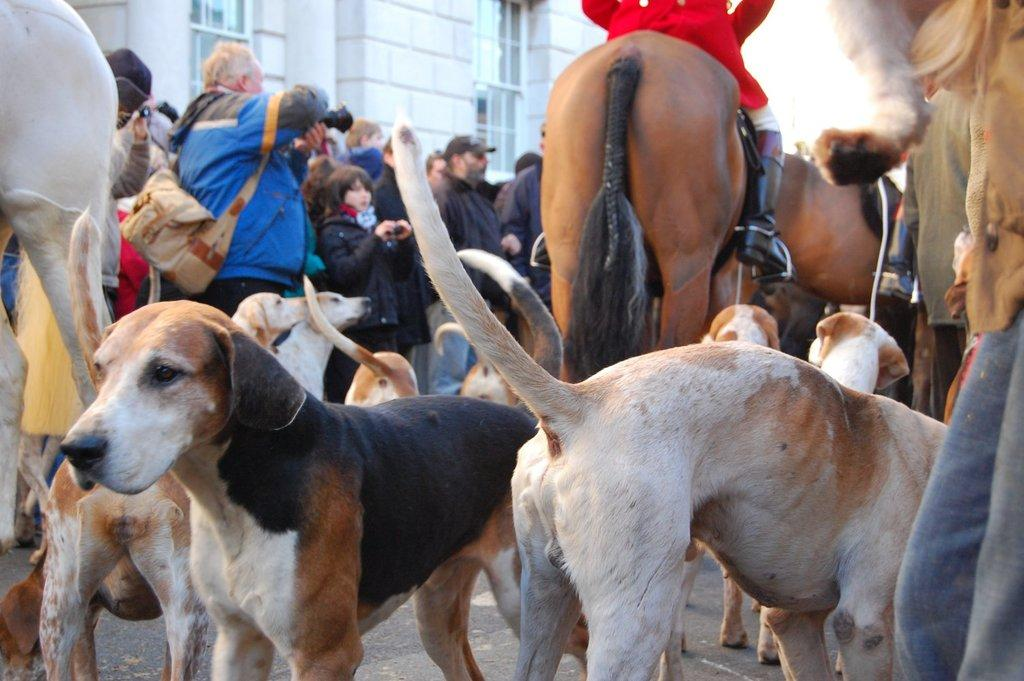What animals are present in the image? There are dogs and horses in the image. Are there any humans in the image? Yes, there are people standing in the image. What can be seen in the background of the image? There is a building in the background of the image. What type of texture can be seen on the tail of the house in the image? There is no house present in the image, and therefore no tail or texture to observe. 